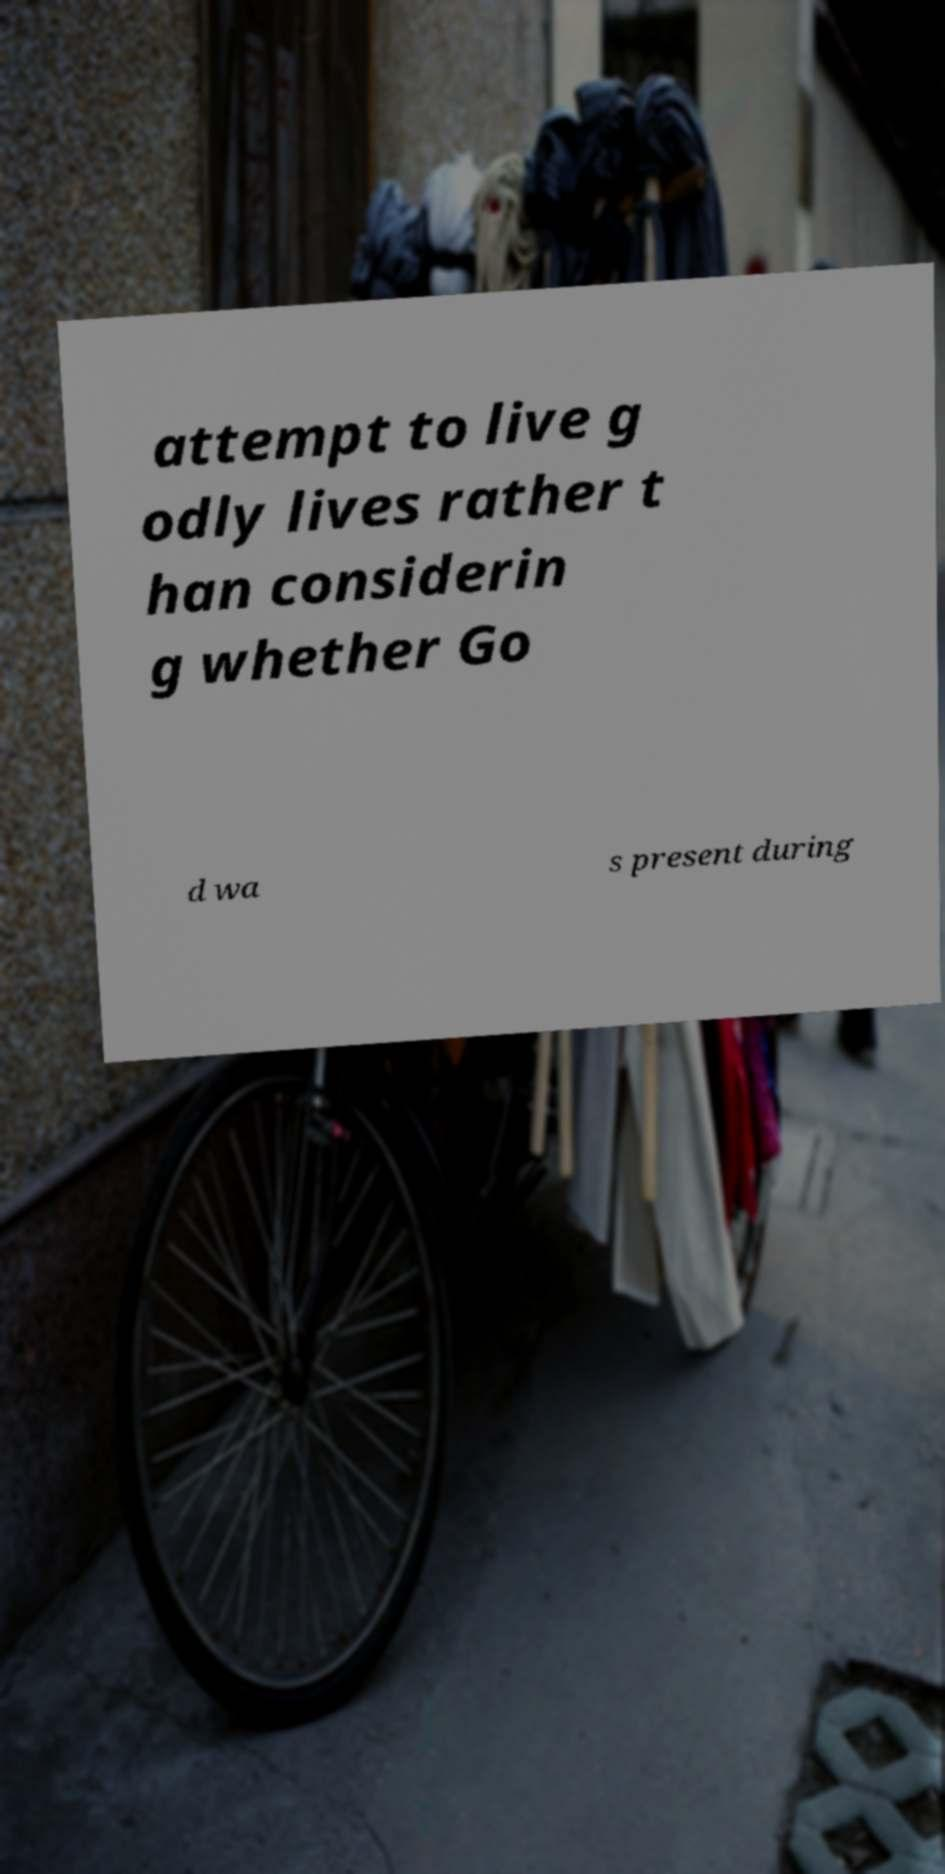Can you read and provide the text displayed in the image?This photo seems to have some interesting text. Can you extract and type it out for me? attempt to live g odly lives rather t han considerin g whether Go d wa s present during 